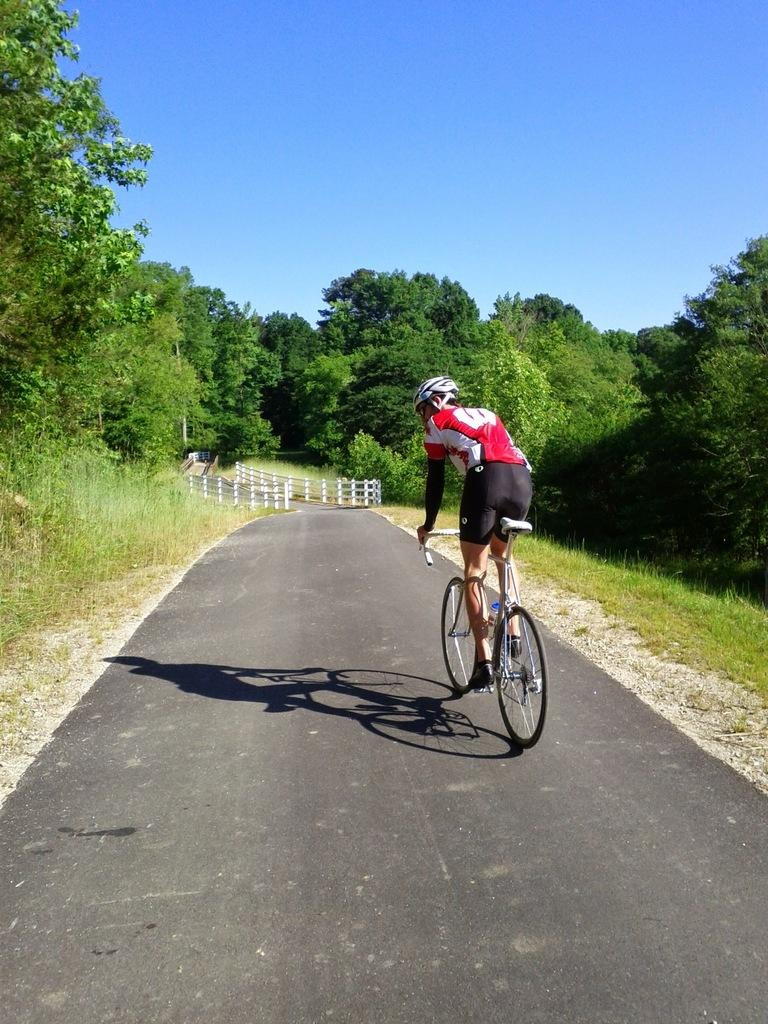What is the main subject of the image? There is a person riding a bicycle in the image. Where is the person riding the bicycle? The person is on a road. What can be seen on either side of the road? There are trees on either side of the road. What is in front of the person riding the bicycle? There is a bridge in front of the person. What type of cracker is the person holding while riding the bicycle? There is no cracker present in the image; the person is riding a bicycle and there is no indication of any food item. 